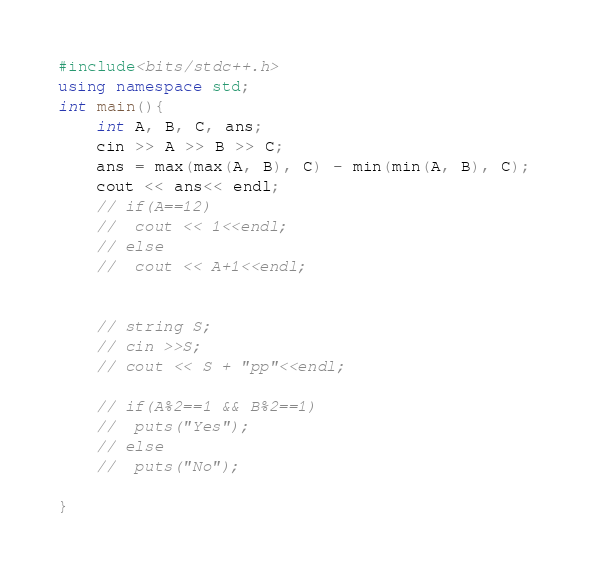Convert code to text. <code><loc_0><loc_0><loc_500><loc_500><_C++_>#include<bits/stdc++.h>
using namespace std;
int main(){
    int A, B, C, ans;
    cin >> A >> B >> C;
    ans = max(max(A, B), C) - min(min(A, B), C);
    cout << ans<< endl;
    // if(A==12)
    // 	cout << 1<<endl;
    // else
    // 	cout << A+1<<endl;
    

    // string S;
    // cin >>S;
    // cout << S + "pp"<<endl;

    // if(A%2==1 && B%2==1)
    // 	puts("Yes");
    // else
    // 	puts("No");
	
}
</code> 